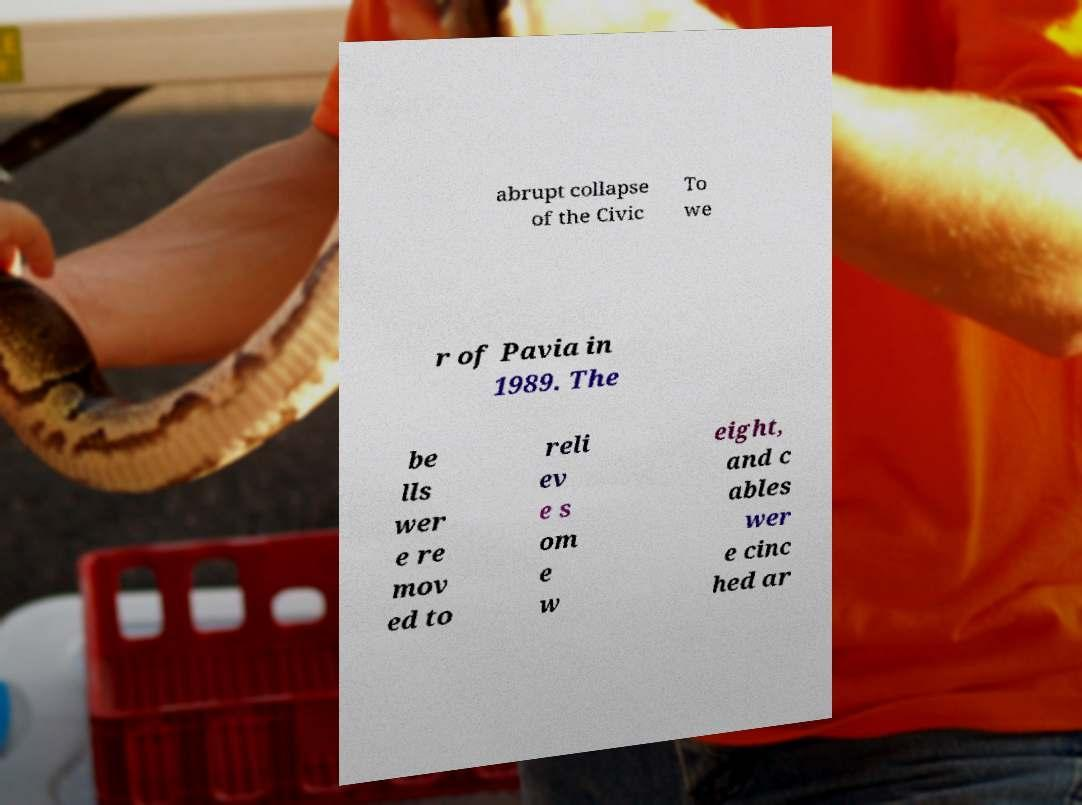I need the written content from this picture converted into text. Can you do that? abrupt collapse of the Civic To we r of Pavia in 1989. The be lls wer e re mov ed to reli ev e s om e w eight, and c ables wer e cinc hed ar 